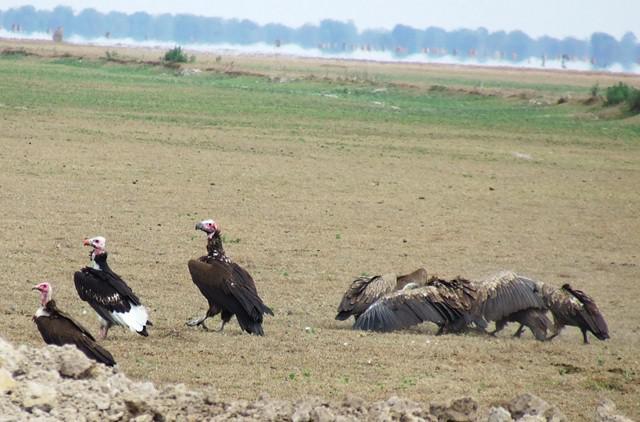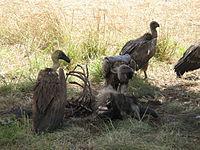The first image is the image on the left, the second image is the image on the right. For the images displayed, is the sentence "A body of water is visible in one of the images." factually correct? Answer yes or no. No. The first image is the image on the left, the second image is the image on the right. For the images shown, is this caption "there is water in the image on the right" true? Answer yes or no. No. The first image is the image on the left, the second image is the image on the right. For the images shown, is this caption "There is water in the image on the left." true? Answer yes or no. No. 